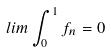Convert formula to latex. <formula><loc_0><loc_0><loc_500><loc_500>l i m \int _ { 0 } ^ { 1 } f _ { n } = 0</formula> 